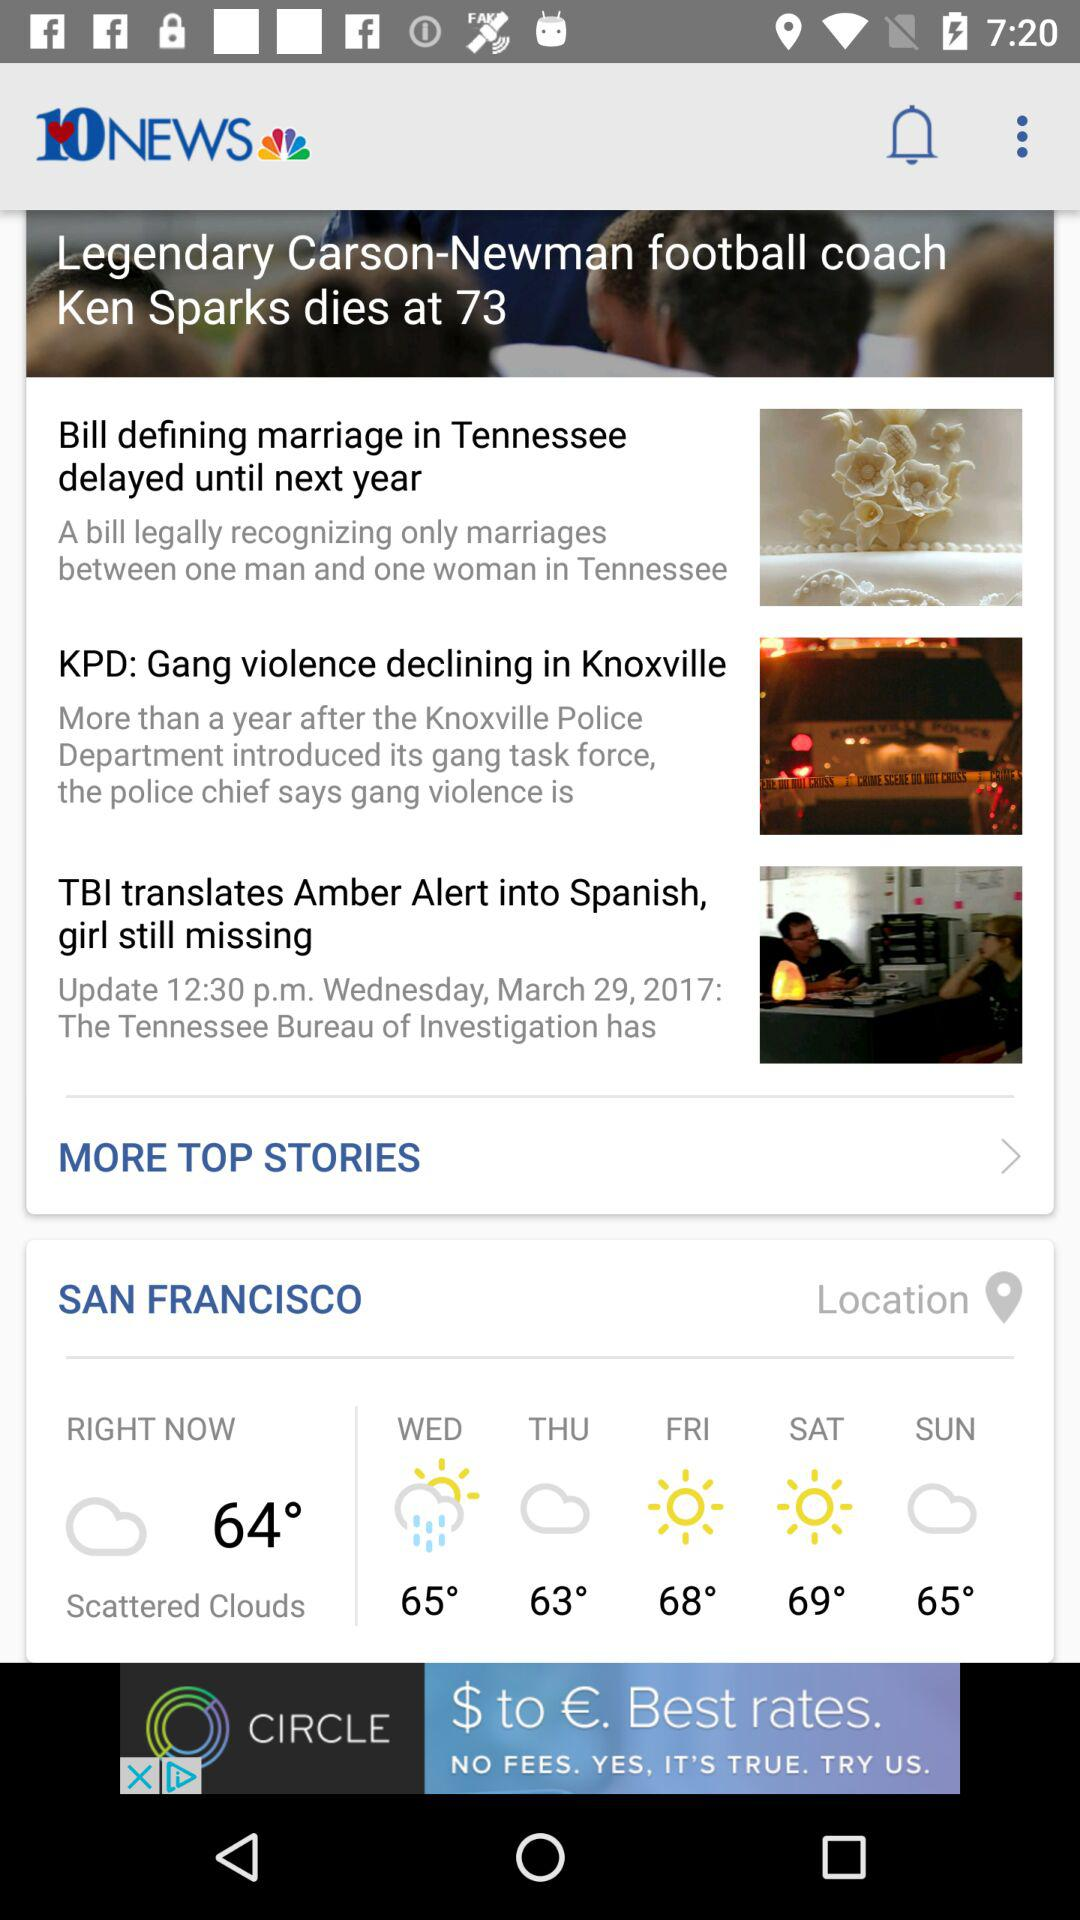What is Friday's temperature showing on the screen? The shown temperature is 68°. 